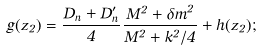Convert formula to latex. <formula><loc_0><loc_0><loc_500><loc_500>g ( z _ { 2 } ) = { \frac { D _ { n } + D _ { n } ^ { \prime } } { 4 } } { \frac { M ^ { 2 } + { \delta m } ^ { 2 } } { M ^ { 2 } + k ^ { 2 } / 4 } } + h ( z _ { 2 } ) ;</formula> 